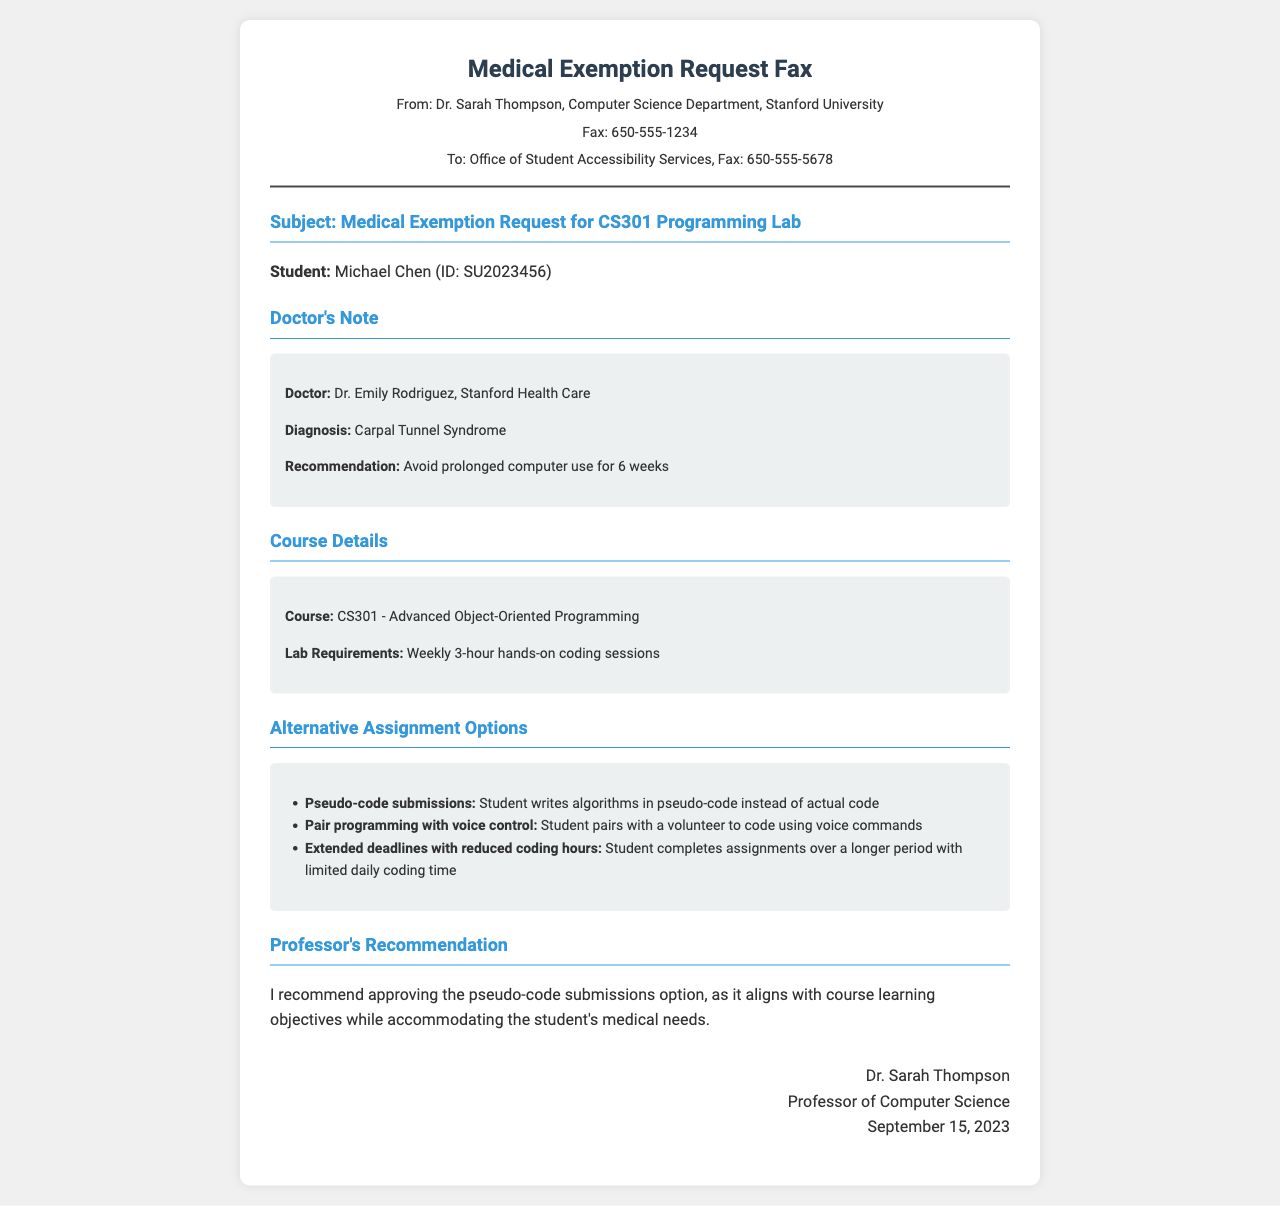What is the student's name? The student's name is stated clearly in the document as Michael Chen.
Answer: Michael Chen What is the diagnosis mentioned in the doctor’s note? The specific diagnosis provided by Dr. Emily Rodriguez is Carpal Tunnel Syndrome.
Answer: Carpal Tunnel Syndrome What are the lab requirements for CS301? The document specifies that lab requirements include weekly 3-hour hands-on coding sessions.
Answer: Weekly 3-hour hands-on coding sessions How long should the student avoid prolonged computer use? The doctor recommends that the student avoid computer use for a period of 6 weeks.
Answer: 6 weeks What is one proposed alternative assignment option? One of the alternative assignment options provided in the document is pseudo-code submissions.
Answer: Pseudo-code submissions Who is the doctor providing the note? The doctor mentioned in the document is Dr. Emily Rodriguez from Stanford Health Care.
Answer: Dr. Emily Rodriguez What date is the fax signed? The fax is signed on September 15, 2023, by Dr. Sarah Thompson.
Answer: September 15, 2023 What is the course title referenced in the fax? The course title given in the document is CS301 - Advanced Object-Oriented Programming.
Answer: CS301 - Advanced Object-Oriented Programming What is Dr. Sarah Thompson's recommendation for alternative assignments? Dr. Sarah Thompson recommends approving the pseudo-code submissions option.
Answer: Approving the pseudo-code submissions option 